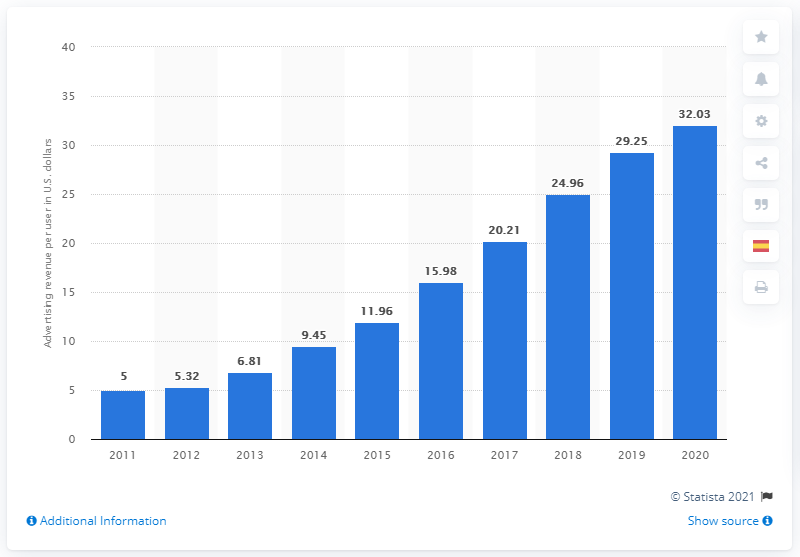Highlight a few significant elements in this photo. Facebook's average advertising revenue per user in 2020 was approximately $32.03. 